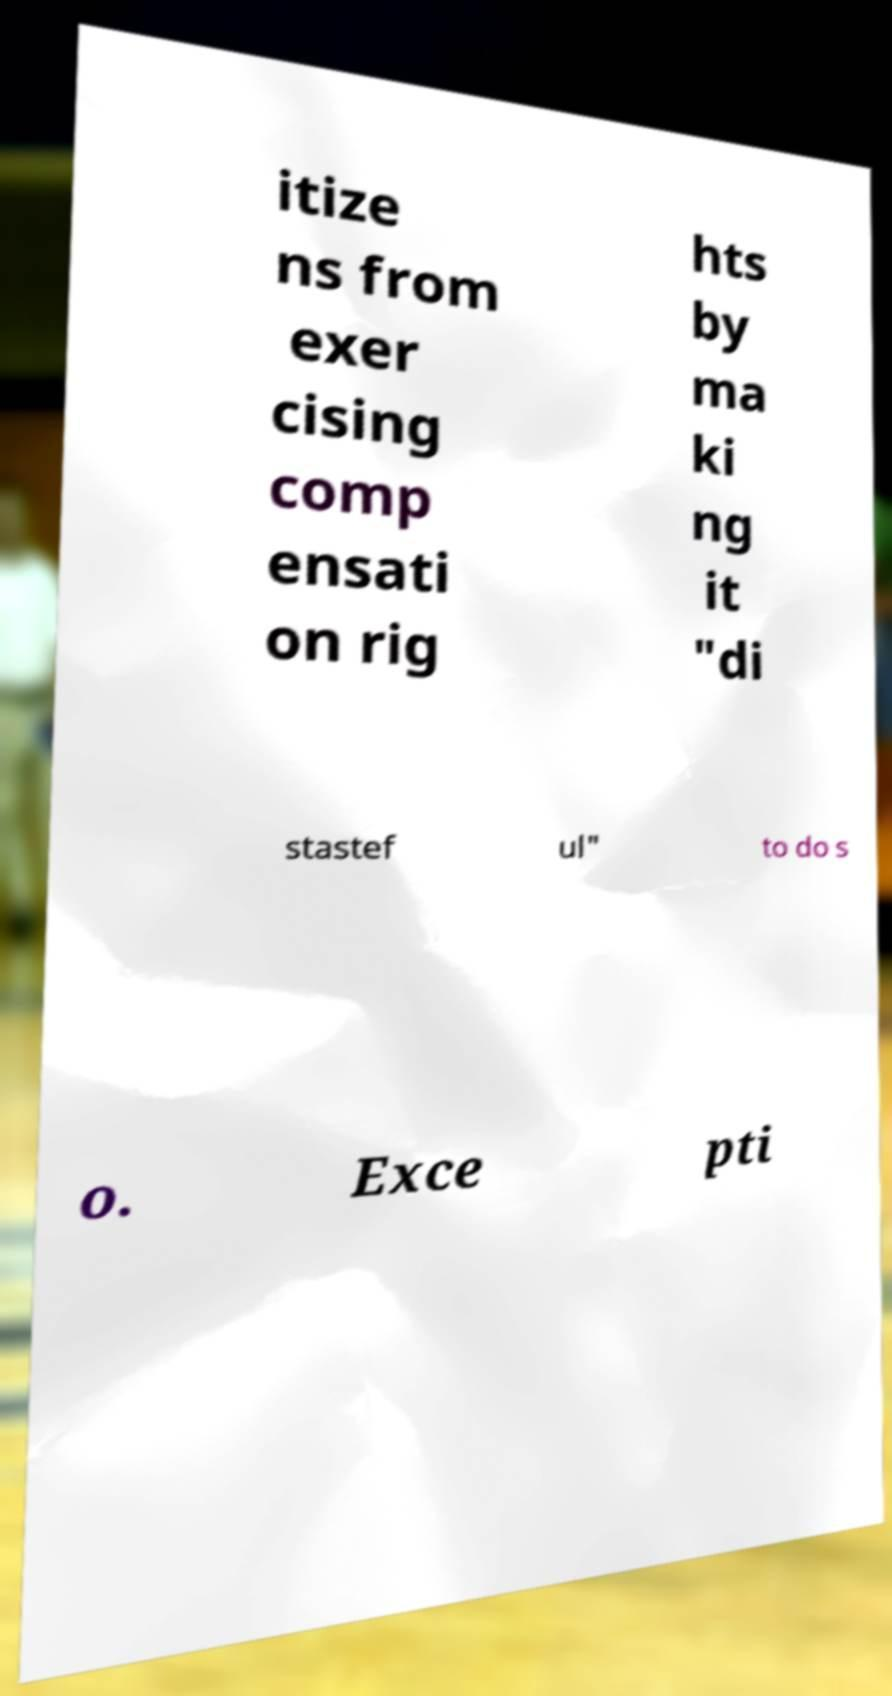What messages or text are displayed in this image? I need them in a readable, typed format. itize ns from exer cising comp ensati on rig hts by ma ki ng it "di stastef ul" to do s o. Exce pti 